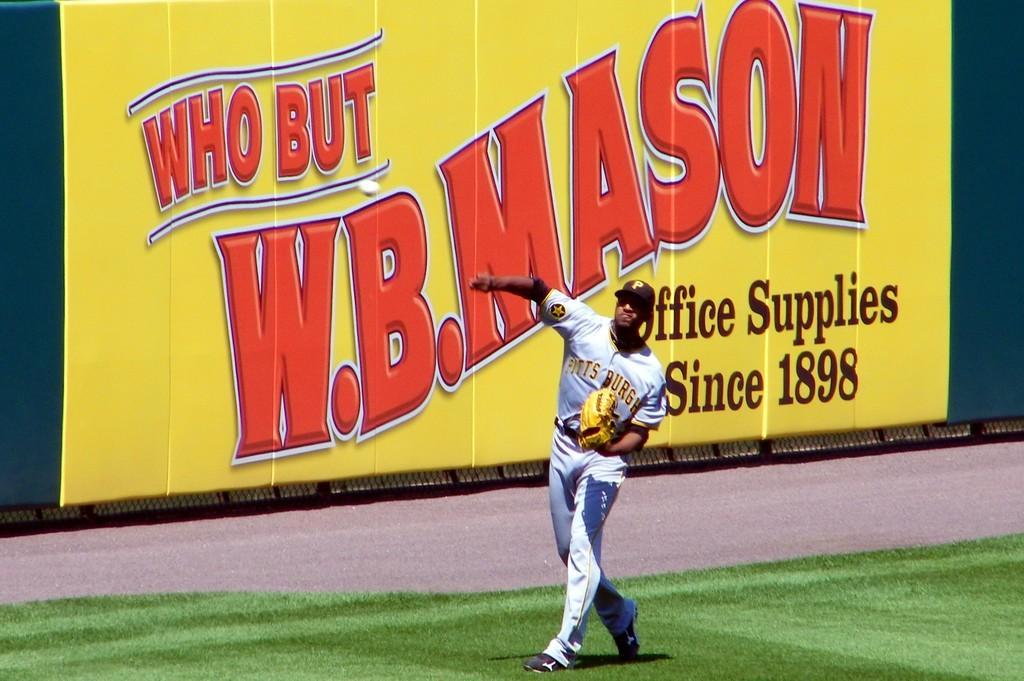<image>
Render a clear and concise summary of the photo. A man in a Pittsburgh jersey throws a baseball in front of an advertisement for W. B. Mason. 